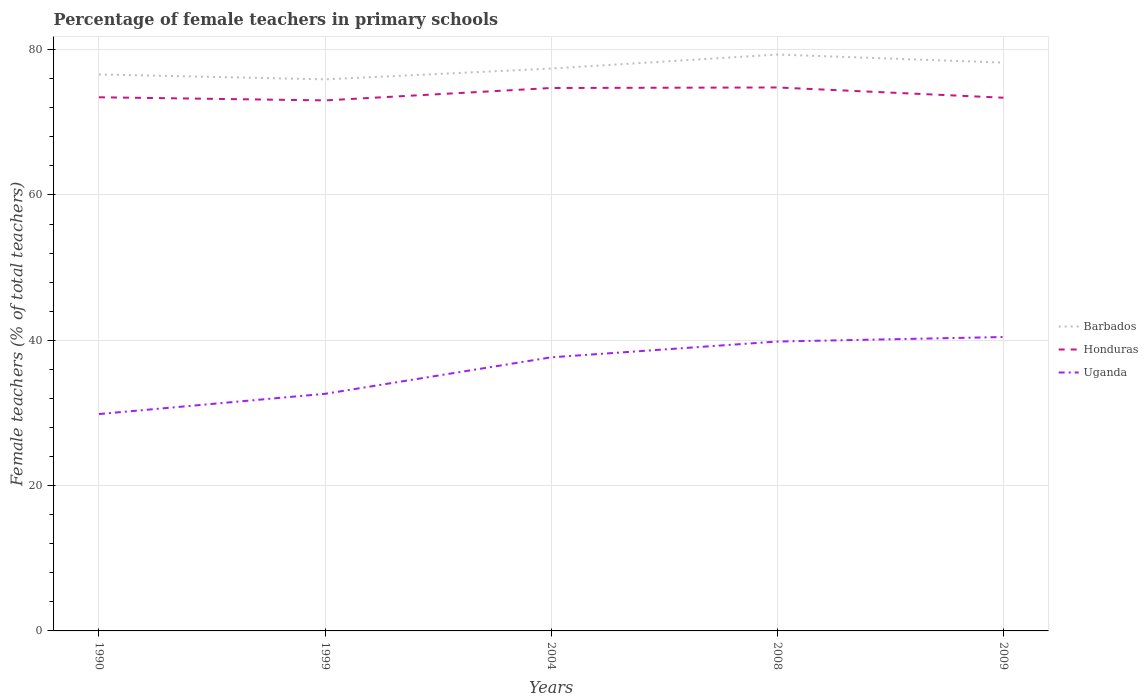Does the line corresponding to Uganda intersect with the line corresponding to Barbados?
Make the answer very short. No. Across all years, what is the maximum percentage of female teachers in Honduras?
Provide a short and direct response. 73.02. What is the total percentage of female teachers in Barbados in the graph?
Provide a succinct answer. -3.41. What is the difference between the highest and the second highest percentage of female teachers in Uganda?
Offer a terse response. 10.6. Is the percentage of female teachers in Uganda strictly greater than the percentage of female teachers in Honduras over the years?
Give a very brief answer. Yes. What is the difference between two consecutive major ticks on the Y-axis?
Make the answer very short. 20. Are the values on the major ticks of Y-axis written in scientific E-notation?
Your answer should be very brief. No. Does the graph contain any zero values?
Offer a very short reply. No. Where does the legend appear in the graph?
Offer a very short reply. Center right. How many legend labels are there?
Keep it short and to the point. 3. How are the legend labels stacked?
Give a very brief answer. Vertical. What is the title of the graph?
Make the answer very short. Percentage of female teachers in primary schools. Does "Afghanistan" appear as one of the legend labels in the graph?
Your response must be concise. No. What is the label or title of the Y-axis?
Provide a succinct answer. Female teachers (% of total teachers). What is the Female teachers (% of total teachers) of Barbados in 1990?
Provide a short and direct response. 76.59. What is the Female teachers (% of total teachers) of Honduras in 1990?
Your answer should be very brief. 73.45. What is the Female teachers (% of total teachers) of Uganda in 1990?
Your answer should be compact. 29.85. What is the Female teachers (% of total teachers) of Barbados in 1999?
Provide a succinct answer. 75.91. What is the Female teachers (% of total teachers) of Honduras in 1999?
Keep it short and to the point. 73.02. What is the Female teachers (% of total teachers) of Uganda in 1999?
Provide a succinct answer. 32.63. What is the Female teachers (% of total teachers) in Barbados in 2004?
Make the answer very short. 77.4. What is the Female teachers (% of total teachers) of Honduras in 2004?
Keep it short and to the point. 74.73. What is the Female teachers (% of total teachers) in Uganda in 2004?
Offer a terse response. 37.66. What is the Female teachers (% of total teachers) in Barbados in 2008?
Your answer should be compact. 79.33. What is the Female teachers (% of total teachers) of Honduras in 2008?
Provide a succinct answer. 74.8. What is the Female teachers (% of total teachers) of Uganda in 2008?
Provide a short and direct response. 39.83. What is the Female teachers (% of total teachers) in Barbados in 2009?
Give a very brief answer. 78.22. What is the Female teachers (% of total teachers) in Honduras in 2009?
Make the answer very short. 73.39. What is the Female teachers (% of total teachers) in Uganda in 2009?
Your answer should be very brief. 40.45. Across all years, what is the maximum Female teachers (% of total teachers) in Barbados?
Offer a very short reply. 79.33. Across all years, what is the maximum Female teachers (% of total teachers) of Honduras?
Your answer should be compact. 74.8. Across all years, what is the maximum Female teachers (% of total teachers) of Uganda?
Make the answer very short. 40.45. Across all years, what is the minimum Female teachers (% of total teachers) of Barbados?
Provide a short and direct response. 75.91. Across all years, what is the minimum Female teachers (% of total teachers) of Honduras?
Make the answer very short. 73.02. Across all years, what is the minimum Female teachers (% of total teachers) in Uganda?
Your answer should be very brief. 29.85. What is the total Female teachers (% of total teachers) of Barbados in the graph?
Keep it short and to the point. 387.46. What is the total Female teachers (% of total teachers) in Honduras in the graph?
Offer a very short reply. 369.38. What is the total Female teachers (% of total teachers) in Uganda in the graph?
Your answer should be compact. 180.42. What is the difference between the Female teachers (% of total teachers) in Barbados in 1990 and that in 1999?
Your response must be concise. 0.68. What is the difference between the Female teachers (% of total teachers) in Honduras in 1990 and that in 1999?
Your response must be concise. 0.43. What is the difference between the Female teachers (% of total teachers) in Uganda in 1990 and that in 1999?
Keep it short and to the point. -2.79. What is the difference between the Female teachers (% of total teachers) of Barbados in 1990 and that in 2004?
Your response must be concise. -0.81. What is the difference between the Female teachers (% of total teachers) of Honduras in 1990 and that in 2004?
Your answer should be compact. -1.28. What is the difference between the Female teachers (% of total teachers) of Uganda in 1990 and that in 2004?
Offer a terse response. -7.81. What is the difference between the Female teachers (% of total teachers) of Barbados in 1990 and that in 2008?
Keep it short and to the point. -2.74. What is the difference between the Female teachers (% of total teachers) of Honduras in 1990 and that in 2008?
Keep it short and to the point. -1.35. What is the difference between the Female teachers (% of total teachers) in Uganda in 1990 and that in 2008?
Your response must be concise. -9.98. What is the difference between the Female teachers (% of total teachers) of Barbados in 1990 and that in 2009?
Provide a short and direct response. -1.63. What is the difference between the Female teachers (% of total teachers) of Honduras in 1990 and that in 2009?
Offer a very short reply. 0.06. What is the difference between the Female teachers (% of total teachers) of Uganda in 1990 and that in 2009?
Your answer should be compact. -10.6. What is the difference between the Female teachers (% of total teachers) of Barbados in 1999 and that in 2004?
Make the answer very short. -1.49. What is the difference between the Female teachers (% of total teachers) of Honduras in 1999 and that in 2004?
Offer a very short reply. -1.71. What is the difference between the Female teachers (% of total teachers) of Uganda in 1999 and that in 2004?
Offer a terse response. -5.02. What is the difference between the Female teachers (% of total teachers) of Barbados in 1999 and that in 2008?
Give a very brief answer. -3.41. What is the difference between the Female teachers (% of total teachers) of Honduras in 1999 and that in 2008?
Your answer should be very brief. -1.78. What is the difference between the Female teachers (% of total teachers) of Uganda in 1999 and that in 2008?
Provide a succinct answer. -7.19. What is the difference between the Female teachers (% of total teachers) of Barbados in 1999 and that in 2009?
Your answer should be compact. -2.31. What is the difference between the Female teachers (% of total teachers) of Honduras in 1999 and that in 2009?
Offer a very short reply. -0.37. What is the difference between the Female teachers (% of total teachers) in Uganda in 1999 and that in 2009?
Your answer should be very brief. -7.82. What is the difference between the Female teachers (% of total teachers) in Barbados in 2004 and that in 2008?
Make the answer very short. -1.93. What is the difference between the Female teachers (% of total teachers) of Honduras in 2004 and that in 2008?
Your answer should be compact. -0.07. What is the difference between the Female teachers (% of total teachers) in Uganda in 2004 and that in 2008?
Offer a terse response. -2.17. What is the difference between the Female teachers (% of total teachers) of Barbados in 2004 and that in 2009?
Give a very brief answer. -0.82. What is the difference between the Female teachers (% of total teachers) of Honduras in 2004 and that in 2009?
Keep it short and to the point. 1.34. What is the difference between the Female teachers (% of total teachers) in Uganda in 2004 and that in 2009?
Make the answer very short. -2.8. What is the difference between the Female teachers (% of total teachers) of Barbados in 2008 and that in 2009?
Provide a succinct answer. 1.11. What is the difference between the Female teachers (% of total teachers) in Honduras in 2008 and that in 2009?
Offer a very short reply. 1.41. What is the difference between the Female teachers (% of total teachers) in Uganda in 2008 and that in 2009?
Give a very brief answer. -0.62. What is the difference between the Female teachers (% of total teachers) in Barbados in 1990 and the Female teachers (% of total teachers) in Honduras in 1999?
Provide a succinct answer. 3.57. What is the difference between the Female teachers (% of total teachers) in Barbados in 1990 and the Female teachers (% of total teachers) in Uganda in 1999?
Ensure brevity in your answer.  43.96. What is the difference between the Female teachers (% of total teachers) in Honduras in 1990 and the Female teachers (% of total teachers) in Uganda in 1999?
Provide a short and direct response. 40.81. What is the difference between the Female teachers (% of total teachers) in Barbados in 1990 and the Female teachers (% of total teachers) in Honduras in 2004?
Provide a short and direct response. 1.87. What is the difference between the Female teachers (% of total teachers) of Barbados in 1990 and the Female teachers (% of total teachers) of Uganda in 2004?
Keep it short and to the point. 38.94. What is the difference between the Female teachers (% of total teachers) in Honduras in 1990 and the Female teachers (% of total teachers) in Uganda in 2004?
Your answer should be very brief. 35.79. What is the difference between the Female teachers (% of total teachers) of Barbados in 1990 and the Female teachers (% of total teachers) of Honduras in 2008?
Provide a short and direct response. 1.79. What is the difference between the Female teachers (% of total teachers) of Barbados in 1990 and the Female teachers (% of total teachers) of Uganda in 2008?
Provide a succinct answer. 36.76. What is the difference between the Female teachers (% of total teachers) of Honduras in 1990 and the Female teachers (% of total teachers) of Uganda in 2008?
Give a very brief answer. 33.62. What is the difference between the Female teachers (% of total teachers) in Barbados in 1990 and the Female teachers (% of total teachers) in Honduras in 2009?
Provide a succinct answer. 3.2. What is the difference between the Female teachers (% of total teachers) in Barbados in 1990 and the Female teachers (% of total teachers) in Uganda in 2009?
Provide a short and direct response. 36.14. What is the difference between the Female teachers (% of total teachers) in Honduras in 1990 and the Female teachers (% of total teachers) in Uganda in 2009?
Ensure brevity in your answer.  33. What is the difference between the Female teachers (% of total teachers) in Barbados in 1999 and the Female teachers (% of total teachers) in Honduras in 2004?
Your response must be concise. 1.19. What is the difference between the Female teachers (% of total teachers) in Barbados in 1999 and the Female teachers (% of total teachers) in Uganda in 2004?
Your answer should be very brief. 38.26. What is the difference between the Female teachers (% of total teachers) of Honduras in 1999 and the Female teachers (% of total teachers) of Uganda in 2004?
Provide a short and direct response. 35.36. What is the difference between the Female teachers (% of total teachers) of Barbados in 1999 and the Female teachers (% of total teachers) of Honduras in 2008?
Your answer should be compact. 1.12. What is the difference between the Female teachers (% of total teachers) in Barbados in 1999 and the Female teachers (% of total teachers) in Uganda in 2008?
Keep it short and to the point. 36.09. What is the difference between the Female teachers (% of total teachers) in Honduras in 1999 and the Female teachers (% of total teachers) in Uganda in 2008?
Ensure brevity in your answer.  33.19. What is the difference between the Female teachers (% of total teachers) in Barbados in 1999 and the Female teachers (% of total teachers) in Honduras in 2009?
Provide a short and direct response. 2.53. What is the difference between the Female teachers (% of total teachers) of Barbados in 1999 and the Female teachers (% of total teachers) of Uganda in 2009?
Give a very brief answer. 35.46. What is the difference between the Female teachers (% of total teachers) in Honduras in 1999 and the Female teachers (% of total teachers) in Uganda in 2009?
Keep it short and to the point. 32.57. What is the difference between the Female teachers (% of total teachers) of Barbados in 2004 and the Female teachers (% of total teachers) of Honduras in 2008?
Your answer should be compact. 2.6. What is the difference between the Female teachers (% of total teachers) in Barbados in 2004 and the Female teachers (% of total teachers) in Uganda in 2008?
Provide a succinct answer. 37.57. What is the difference between the Female teachers (% of total teachers) in Honduras in 2004 and the Female teachers (% of total teachers) in Uganda in 2008?
Provide a short and direct response. 34.9. What is the difference between the Female teachers (% of total teachers) in Barbados in 2004 and the Female teachers (% of total teachers) in Honduras in 2009?
Make the answer very short. 4.01. What is the difference between the Female teachers (% of total teachers) of Barbados in 2004 and the Female teachers (% of total teachers) of Uganda in 2009?
Keep it short and to the point. 36.95. What is the difference between the Female teachers (% of total teachers) of Honduras in 2004 and the Female teachers (% of total teachers) of Uganda in 2009?
Give a very brief answer. 34.27. What is the difference between the Female teachers (% of total teachers) in Barbados in 2008 and the Female teachers (% of total teachers) in Honduras in 2009?
Provide a short and direct response. 5.94. What is the difference between the Female teachers (% of total teachers) of Barbados in 2008 and the Female teachers (% of total teachers) of Uganda in 2009?
Ensure brevity in your answer.  38.88. What is the difference between the Female teachers (% of total teachers) in Honduras in 2008 and the Female teachers (% of total teachers) in Uganda in 2009?
Your answer should be compact. 34.35. What is the average Female teachers (% of total teachers) of Barbados per year?
Offer a very short reply. 77.49. What is the average Female teachers (% of total teachers) in Honduras per year?
Your answer should be compact. 73.88. What is the average Female teachers (% of total teachers) of Uganda per year?
Your response must be concise. 36.08. In the year 1990, what is the difference between the Female teachers (% of total teachers) of Barbados and Female teachers (% of total teachers) of Honduras?
Your response must be concise. 3.14. In the year 1990, what is the difference between the Female teachers (% of total teachers) of Barbados and Female teachers (% of total teachers) of Uganda?
Ensure brevity in your answer.  46.74. In the year 1990, what is the difference between the Female teachers (% of total teachers) of Honduras and Female teachers (% of total teachers) of Uganda?
Make the answer very short. 43.6. In the year 1999, what is the difference between the Female teachers (% of total teachers) of Barbados and Female teachers (% of total teachers) of Honduras?
Make the answer very short. 2.89. In the year 1999, what is the difference between the Female teachers (% of total teachers) in Barbados and Female teachers (% of total teachers) in Uganda?
Provide a succinct answer. 43.28. In the year 1999, what is the difference between the Female teachers (% of total teachers) in Honduras and Female teachers (% of total teachers) in Uganda?
Provide a short and direct response. 40.38. In the year 2004, what is the difference between the Female teachers (% of total teachers) of Barbados and Female teachers (% of total teachers) of Honduras?
Give a very brief answer. 2.68. In the year 2004, what is the difference between the Female teachers (% of total teachers) in Barbados and Female teachers (% of total teachers) in Uganda?
Keep it short and to the point. 39.74. In the year 2004, what is the difference between the Female teachers (% of total teachers) in Honduras and Female teachers (% of total teachers) in Uganda?
Your response must be concise. 37.07. In the year 2008, what is the difference between the Female teachers (% of total teachers) in Barbados and Female teachers (% of total teachers) in Honduras?
Offer a terse response. 4.53. In the year 2008, what is the difference between the Female teachers (% of total teachers) in Barbados and Female teachers (% of total teachers) in Uganda?
Make the answer very short. 39.5. In the year 2008, what is the difference between the Female teachers (% of total teachers) in Honduras and Female teachers (% of total teachers) in Uganda?
Offer a very short reply. 34.97. In the year 2009, what is the difference between the Female teachers (% of total teachers) in Barbados and Female teachers (% of total teachers) in Honduras?
Make the answer very short. 4.83. In the year 2009, what is the difference between the Female teachers (% of total teachers) of Barbados and Female teachers (% of total teachers) of Uganda?
Keep it short and to the point. 37.77. In the year 2009, what is the difference between the Female teachers (% of total teachers) in Honduras and Female teachers (% of total teachers) in Uganda?
Provide a succinct answer. 32.94. What is the ratio of the Female teachers (% of total teachers) in Barbados in 1990 to that in 1999?
Provide a short and direct response. 1.01. What is the ratio of the Female teachers (% of total teachers) of Honduras in 1990 to that in 1999?
Your answer should be very brief. 1.01. What is the ratio of the Female teachers (% of total teachers) in Uganda in 1990 to that in 1999?
Ensure brevity in your answer.  0.91. What is the ratio of the Female teachers (% of total teachers) in Barbados in 1990 to that in 2004?
Keep it short and to the point. 0.99. What is the ratio of the Female teachers (% of total teachers) in Honduras in 1990 to that in 2004?
Keep it short and to the point. 0.98. What is the ratio of the Female teachers (% of total teachers) of Uganda in 1990 to that in 2004?
Ensure brevity in your answer.  0.79. What is the ratio of the Female teachers (% of total teachers) of Barbados in 1990 to that in 2008?
Provide a succinct answer. 0.97. What is the ratio of the Female teachers (% of total teachers) of Honduras in 1990 to that in 2008?
Offer a very short reply. 0.98. What is the ratio of the Female teachers (% of total teachers) of Uganda in 1990 to that in 2008?
Offer a terse response. 0.75. What is the ratio of the Female teachers (% of total teachers) in Barbados in 1990 to that in 2009?
Offer a very short reply. 0.98. What is the ratio of the Female teachers (% of total teachers) in Honduras in 1990 to that in 2009?
Ensure brevity in your answer.  1. What is the ratio of the Female teachers (% of total teachers) in Uganda in 1990 to that in 2009?
Make the answer very short. 0.74. What is the ratio of the Female teachers (% of total teachers) of Barbados in 1999 to that in 2004?
Offer a terse response. 0.98. What is the ratio of the Female teachers (% of total teachers) of Honduras in 1999 to that in 2004?
Make the answer very short. 0.98. What is the ratio of the Female teachers (% of total teachers) of Uganda in 1999 to that in 2004?
Your response must be concise. 0.87. What is the ratio of the Female teachers (% of total teachers) in Honduras in 1999 to that in 2008?
Give a very brief answer. 0.98. What is the ratio of the Female teachers (% of total teachers) of Uganda in 1999 to that in 2008?
Keep it short and to the point. 0.82. What is the ratio of the Female teachers (% of total teachers) in Barbados in 1999 to that in 2009?
Ensure brevity in your answer.  0.97. What is the ratio of the Female teachers (% of total teachers) of Honduras in 1999 to that in 2009?
Keep it short and to the point. 0.99. What is the ratio of the Female teachers (% of total teachers) in Uganda in 1999 to that in 2009?
Provide a succinct answer. 0.81. What is the ratio of the Female teachers (% of total teachers) of Barbados in 2004 to that in 2008?
Your answer should be compact. 0.98. What is the ratio of the Female teachers (% of total teachers) of Uganda in 2004 to that in 2008?
Ensure brevity in your answer.  0.95. What is the ratio of the Female teachers (% of total teachers) of Honduras in 2004 to that in 2009?
Offer a terse response. 1.02. What is the ratio of the Female teachers (% of total teachers) of Uganda in 2004 to that in 2009?
Give a very brief answer. 0.93. What is the ratio of the Female teachers (% of total teachers) of Barbados in 2008 to that in 2009?
Your answer should be compact. 1.01. What is the ratio of the Female teachers (% of total teachers) in Honduras in 2008 to that in 2009?
Keep it short and to the point. 1.02. What is the ratio of the Female teachers (% of total teachers) of Uganda in 2008 to that in 2009?
Give a very brief answer. 0.98. What is the difference between the highest and the second highest Female teachers (% of total teachers) of Barbados?
Provide a short and direct response. 1.11. What is the difference between the highest and the second highest Female teachers (% of total teachers) of Honduras?
Provide a succinct answer. 0.07. What is the difference between the highest and the lowest Female teachers (% of total teachers) in Barbados?
Provide a succinct answer. 3.41. What is the difference between the highest and the lowest Female teachers (% of total teachers) of Honduras?
Give a very brief answer. 1.78. What is the difference between the highest and the lowest Female teachers (% of total teachers) in Uganda?
Ensure brevity in your answer.  10.6. 